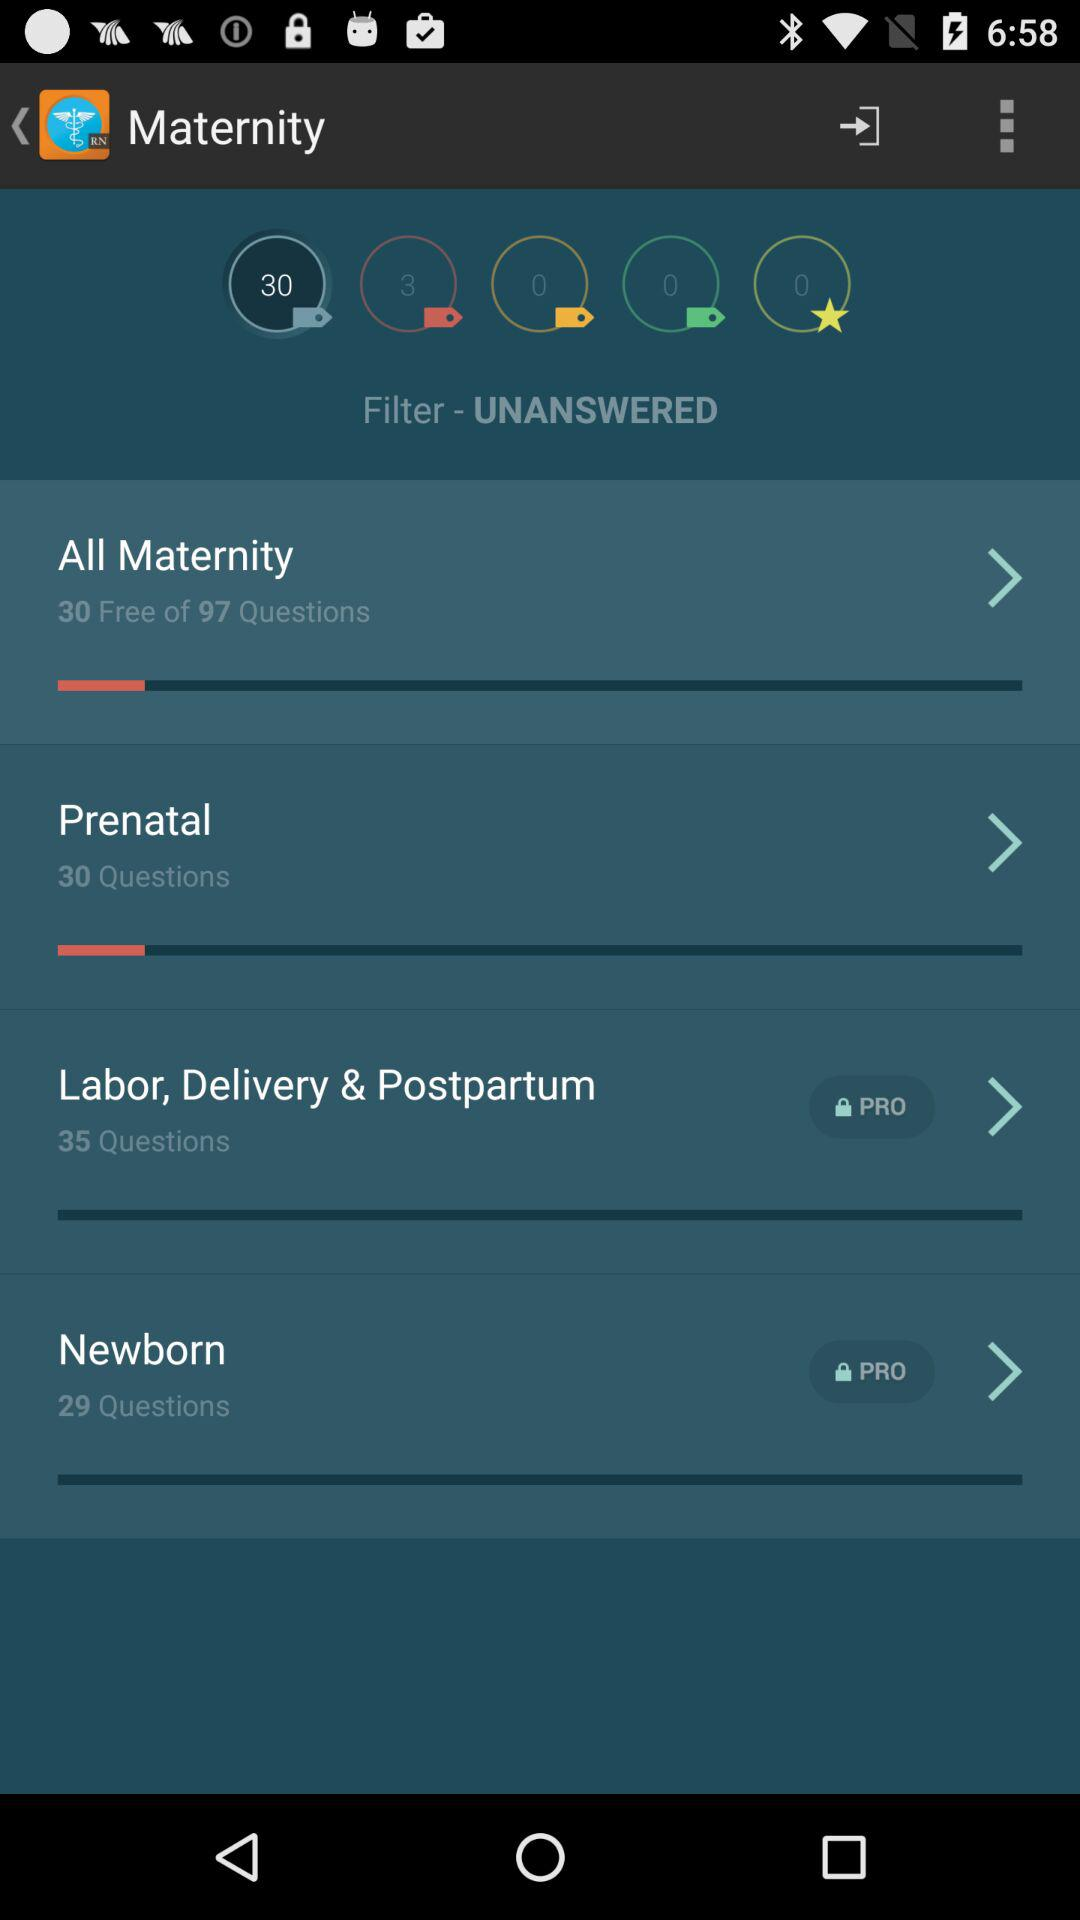How many free questions are there? There are 30 free questions. 